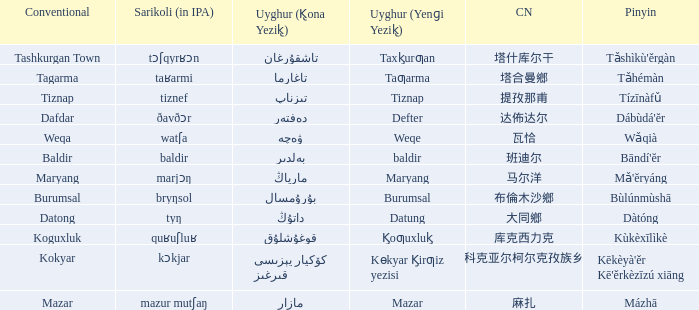Name the pinyin for mazar Mázhā. 